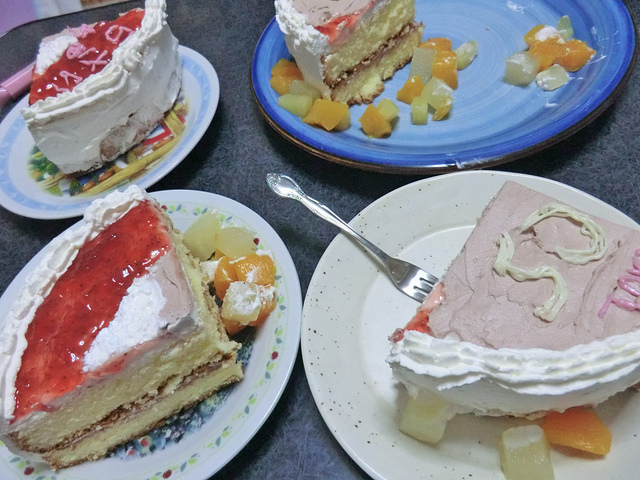Please transcribe the text information in this image. SO 